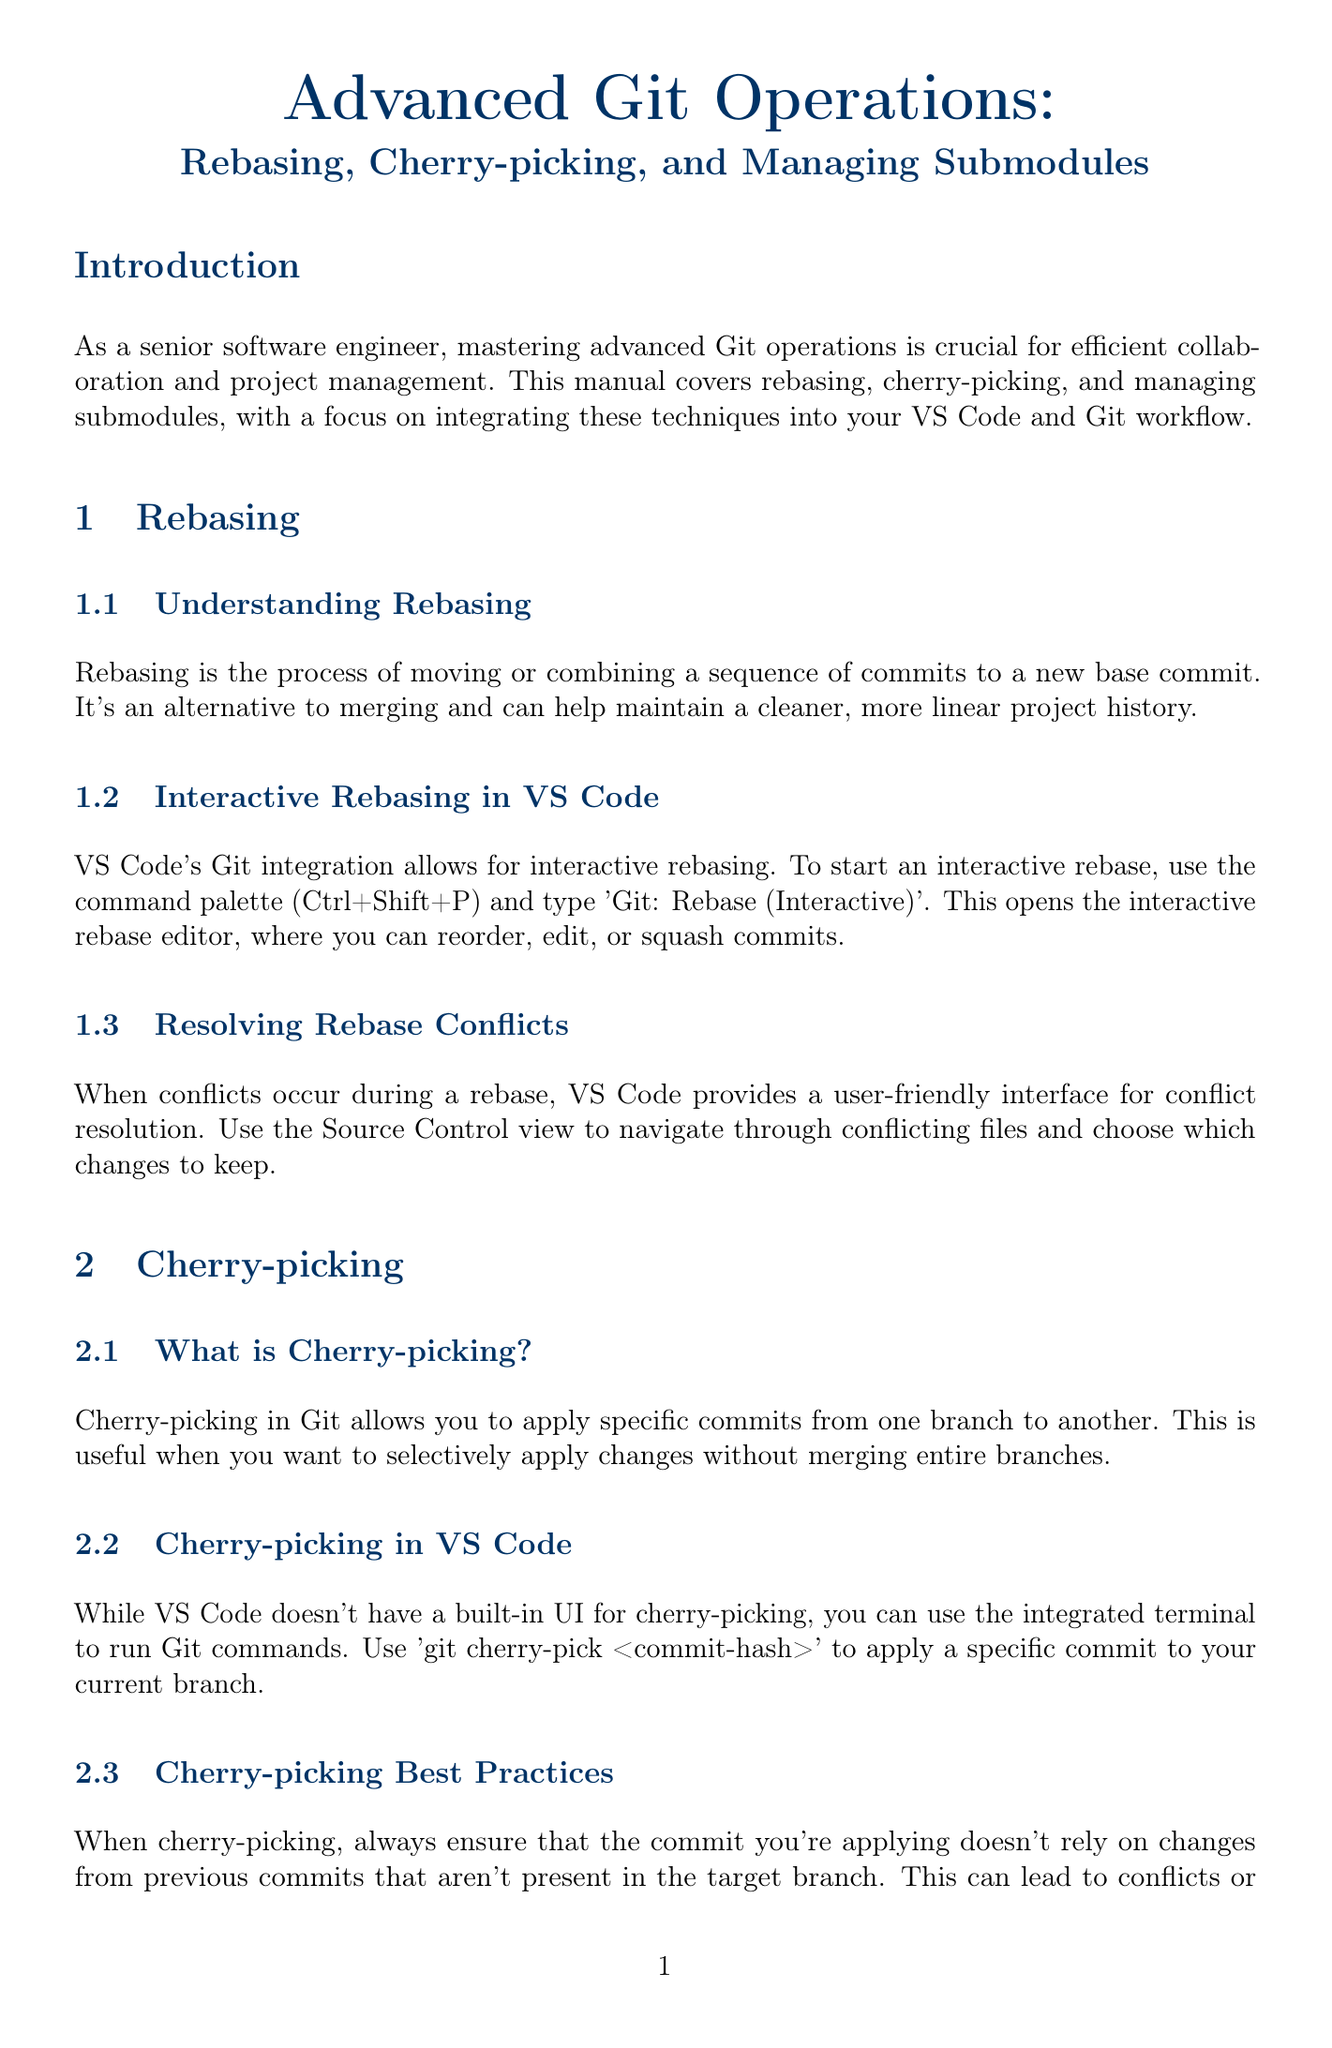What is the main focus of the manual? The manual focuses on advanced Git operations like rebasing, cherry-picking, and managing submodules for efficient collaboration and project management.
Answer: Advanced Git operations What is rebasing? Rebasing is defined as the process of moving or combining a sequence of commits to a new base commit.
Answer: Moving or combining commits What command opens the interactive rebase editor in VS Code? The command to open the interactive rebase editor is found by using the command palette and typing 'Git: Rebase (Interactive)'.
Answer: Git: Rebase (Interactive) What does cherry-picking allow you to do? Cherry-picking allows you to apply specific commits from one branch to another without merging entire branches.
Answer: Apply specific commits What should you ensure when cherry-picking? When cherry-picking, you should ensure that the commit applied doesn't rely on changes from previous commits that aren't present in the target branch.
Answer: No reliance on missing changes How can you add a submodule in VS Code? You can add a submodule by using the integrated terminal and running the command 'git submodule add <repository-url> <path>'.
Answer: git submodule add <repository-url> <path> What is a recommended VS Code extension for Git visualization? One recommended extension for Git visualization in VS Code is 'GitLens'.
Answer: GitLens What is the purpose of creating custom tasks in VS Code? The purpose of creating custom tasks is to automate complex Git operations, such as performing a rebase and pushing changes in one command.
Answer: Automate complex Git operations What is a best practice before performing advanced Git operations? A best practice is to always communicate with your team before performing advanced operations on shared branches.
Answer: Communicate with your team 